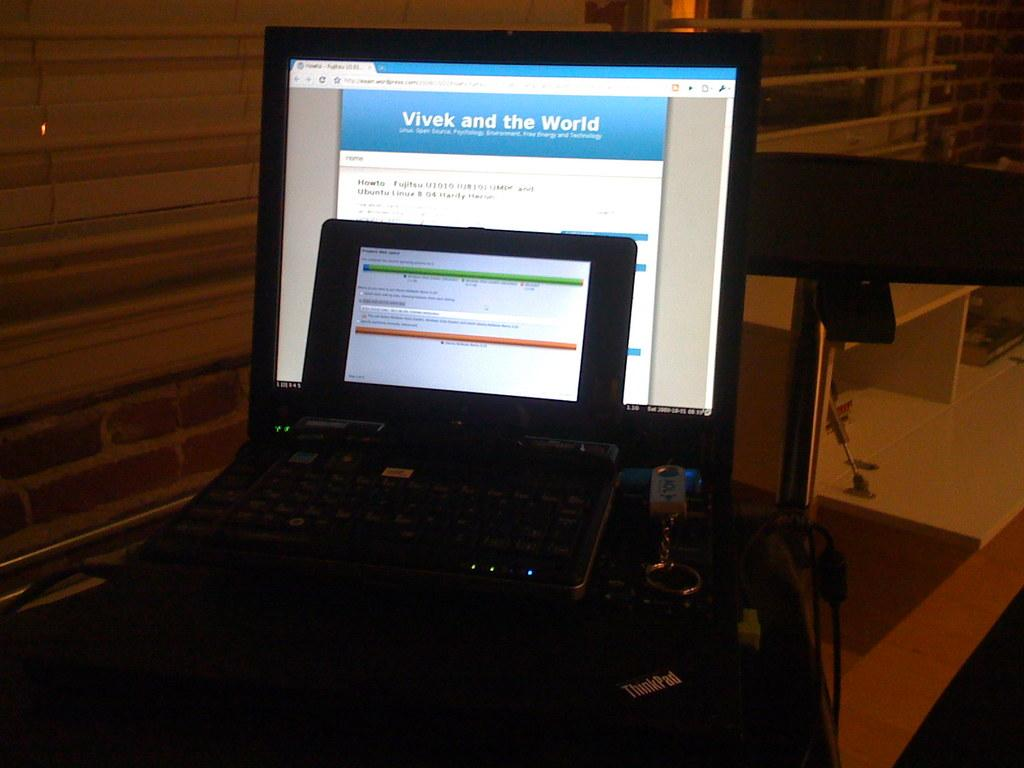What electronic devices are located in the middle of the image? There are laptops in the middle of the image. What small accessory can be seen in the image? There is a key chain in the image. What type of storage or display feature is on the right side of the image? There are shelves on the right side of the image. What type of amusement can be seen on the laptops in the image? There is no amusement present on the laptops in the image; they are simply electronic devices. What type of cream is being used to decorate the key chain in the image? There is no cream present on the key chain in the image; it is a small accessory without any cream. 